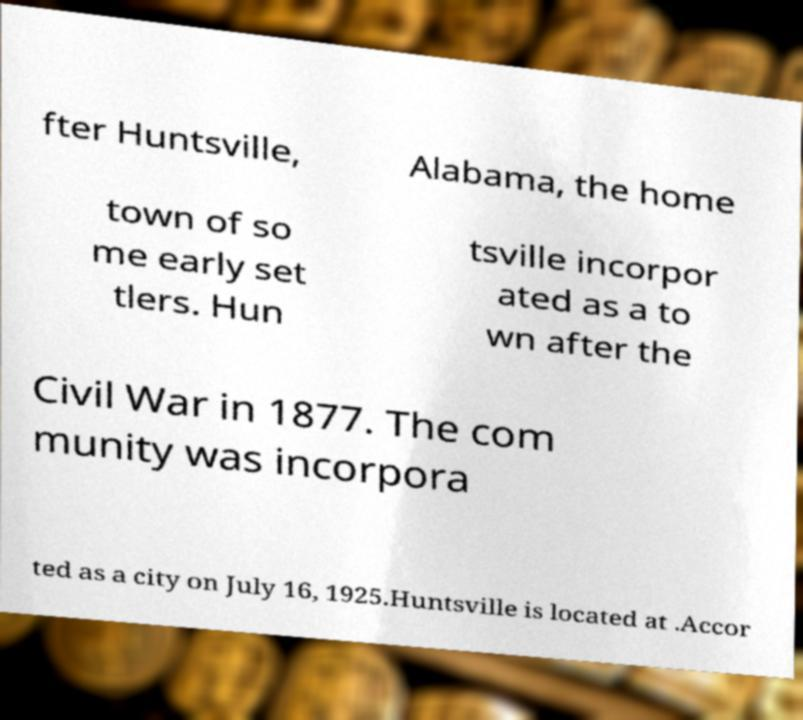Can you accurately transcribe the text from the provided image for me? fter Huntsville, Alabama, the home town of so me early set tlers. Hun tsville incorpor ated as a to wn after the Civil War in 1877. The com munity was incorpora ted as a city on July 16, 1925.Huntsville is located at .Accor 